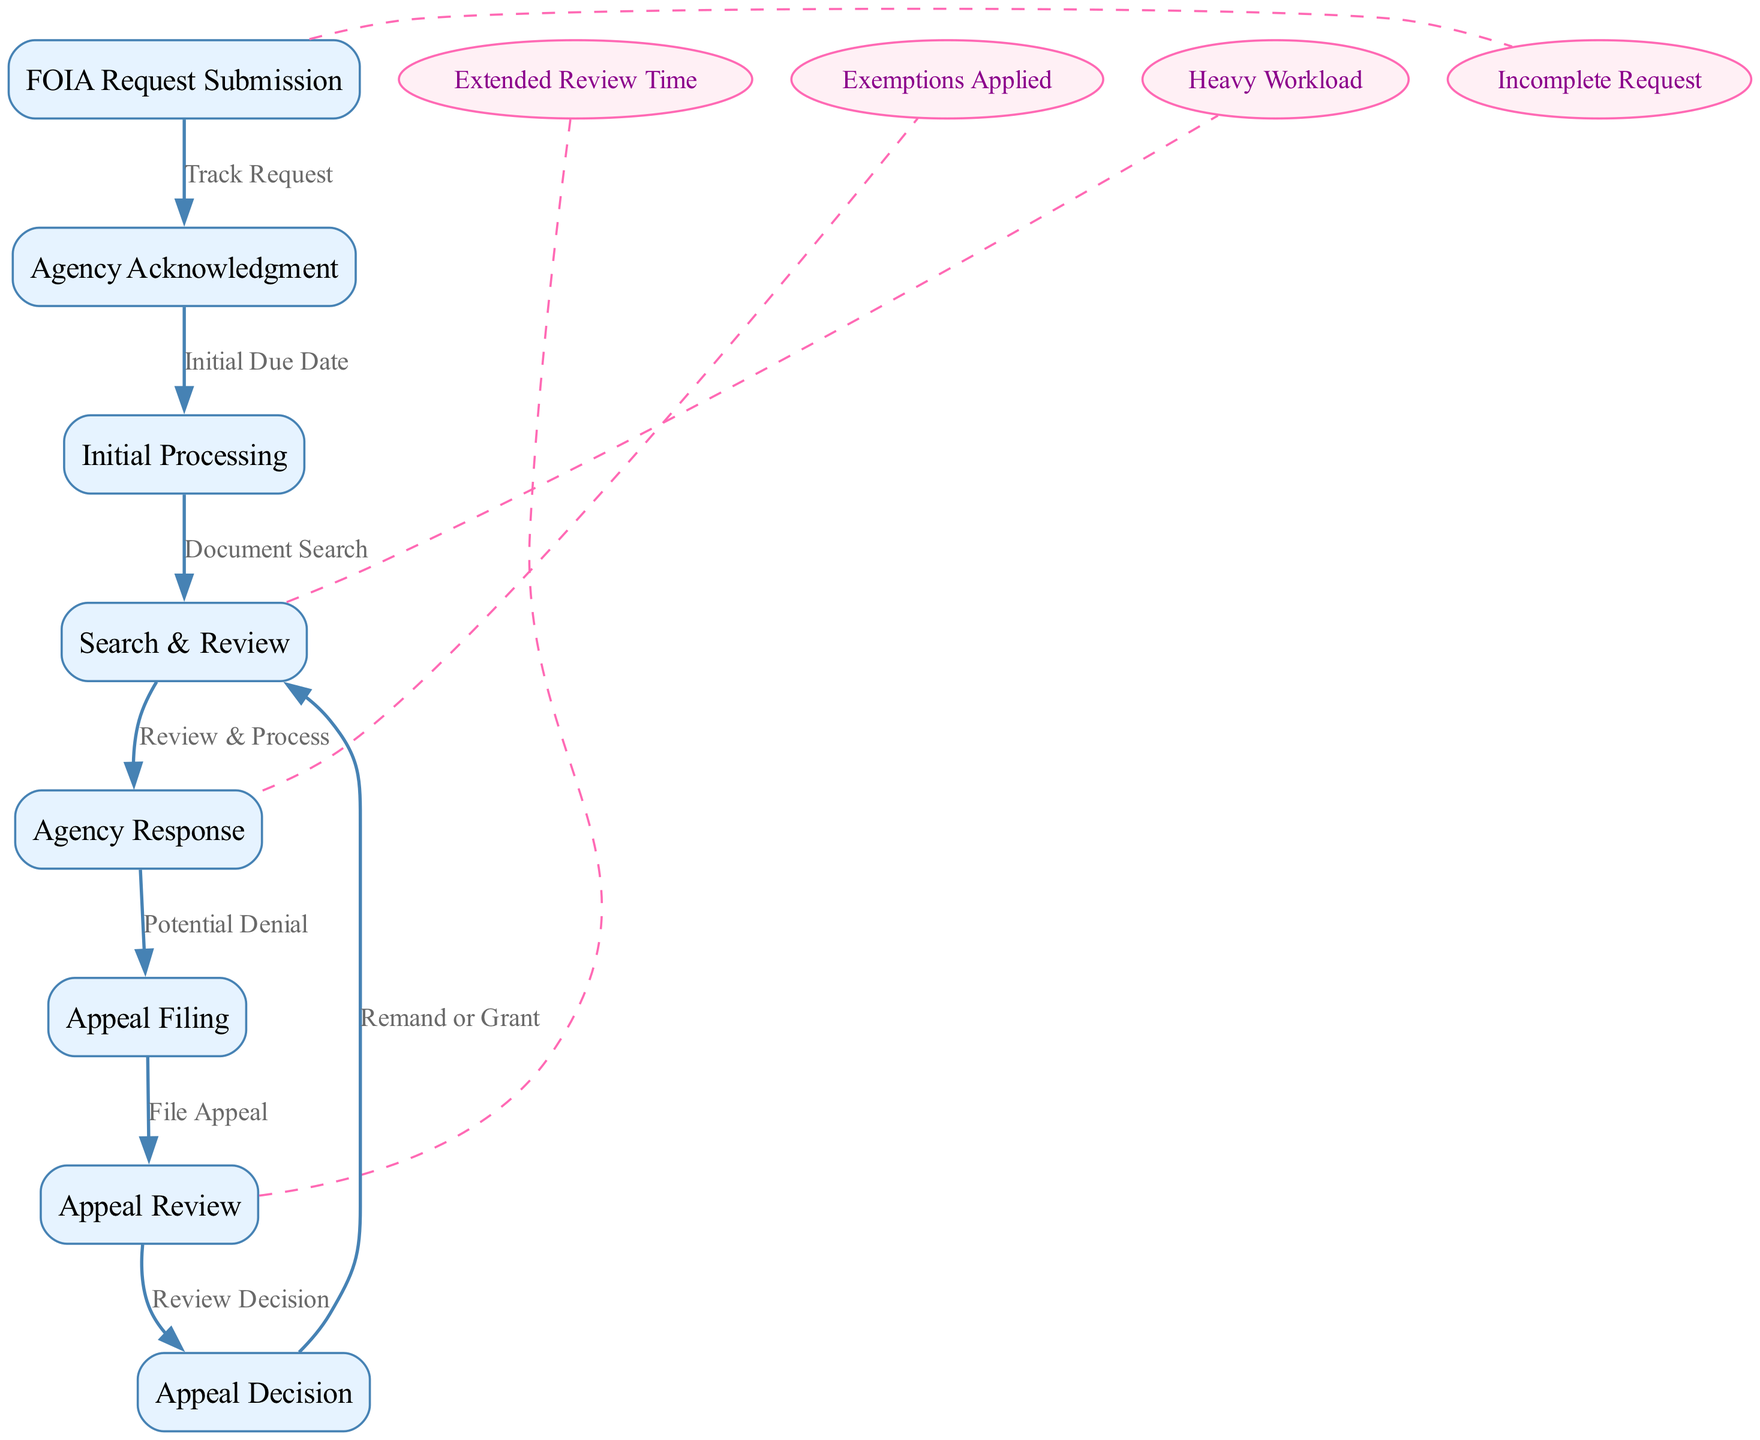What is the first step in the FOIA request lifecycle? The first step in the FOIA request lifecycle, as depicted in the diagram, is the "FOIA Request Submission" node, where the request is initiated by the requester.
Answer: FOIA Request Submission What follows the Agency Acknowledgment? After the "Agency Acknowledgment" node, the diagram indicates that the next step is "Initial Processing," as represented by an edge pointing from acknowledgment to processing.
Answer: Initial Processing How many nodes are there in the diagram? By counting each labeled node in the diagram provided, there are a total of eight nodes.
Answer: Eight What stage has a potential delay labeled "Heavy Workload"? The delay labeled "Heavy Workload" occurs during the "Search & Review" stage, as indicated by the dashed edge leading from this node to the corresponding delay node.
Answer: Search & Review If an appeal is filed, what is the next step? Once an appeal is filed, the next step in the process is "Appeal Review," as shown by the edge connecting from "Appeal Filing" to "Appeal Review."
Answer: Appeal Review What leads to a potential denial in the FOIA process? A potential denial in the FOIA process is indicated to occur after the "Agency Response" node, where responses may result in denials of requests.
Answer: Agency Response How does an appeal decision affect the Search & Review stage? After the "Appeal Decision" stage, if the decision results in a remand or grant, it leads back to the "Search & Review," allowing further processing to take place.
Answer: Search & Review What represents an incomplete request delay in the diagram? The diagram indicates that an "Incomplete Request" leads to a delay associated with the "FOIA Request Submission" stage, shown by a dashed edge linking to the corresponding delay node.
Answer: FOIA Request Submission What is the final outcome of the Appeal Review process? The final step that follows the "Appeal Review" is determining the "Appeal Decision," which concludes the appeal process based on the review.
Answer: Appeal Decision 